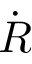<formula> <loc_0><loc_0><loc_500><loc_500>\dot { R }</formula> 